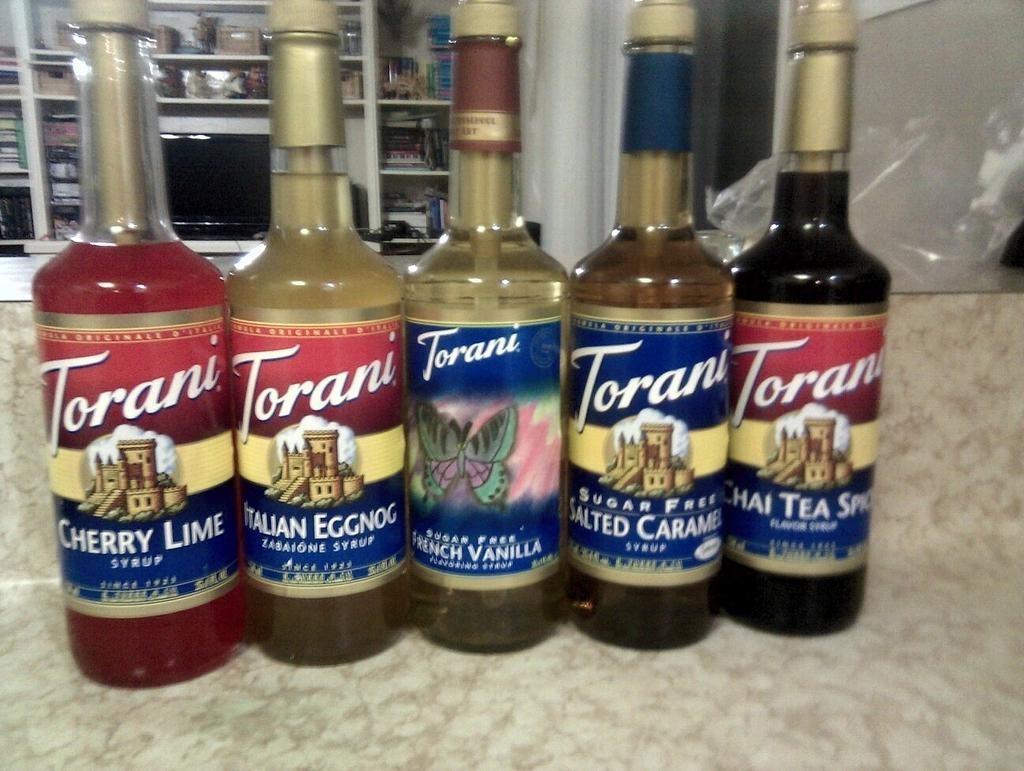Describe this image in one or two sentences. Here we can see a group of bottles on the table, and some liquid in it, and here is the television, and some objects in the shelves. 